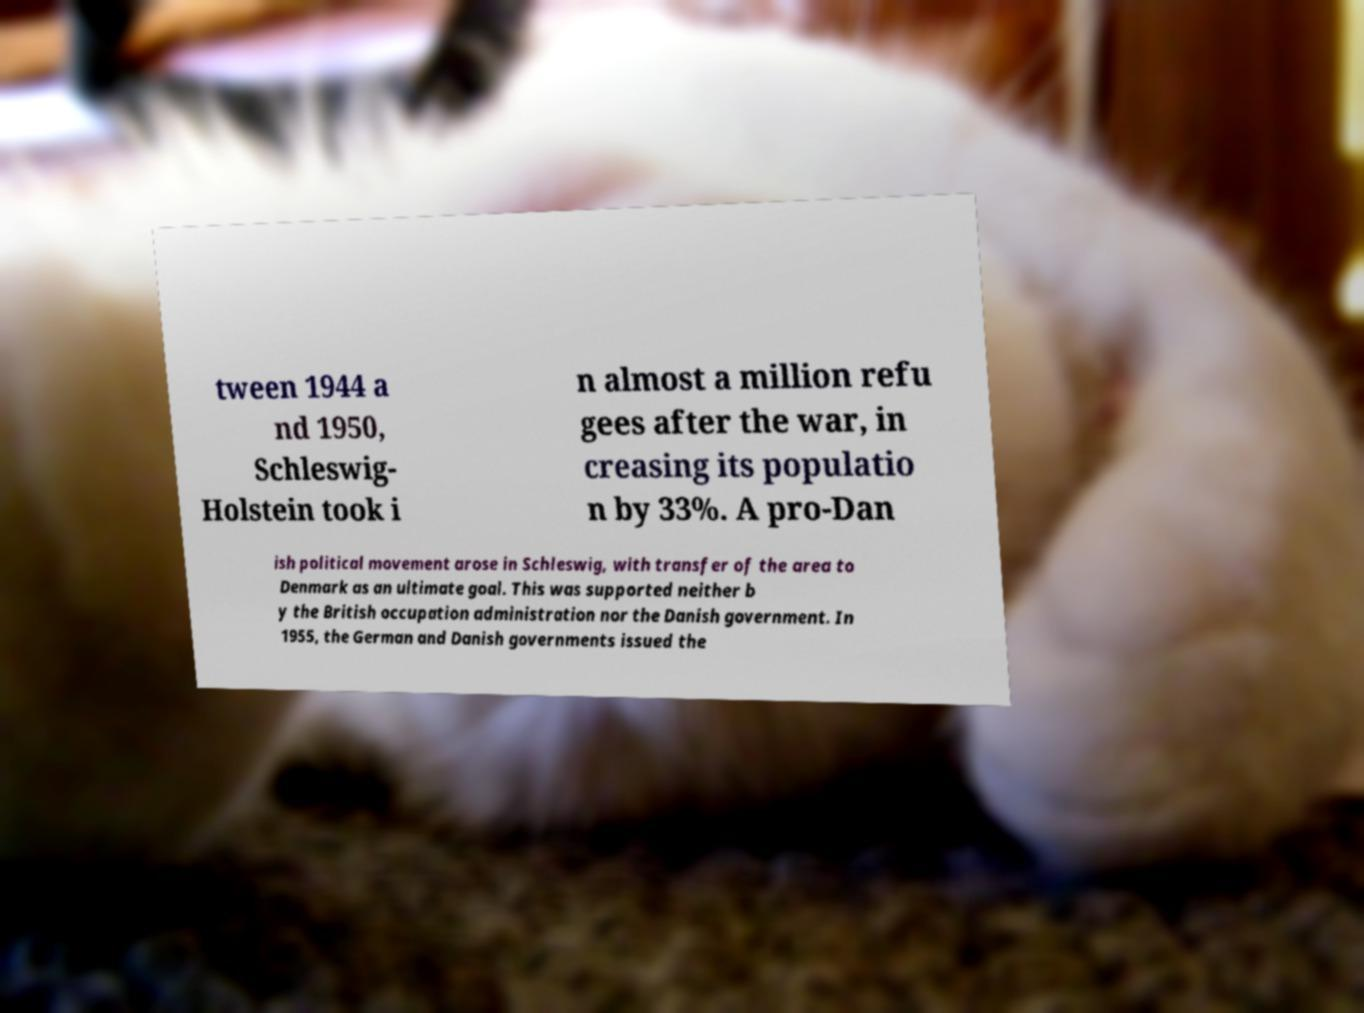Can you accurately transcribe the text from the provided image for me? tween 1944 a nd 1950, Schleswig- Holstein took i n almost a million refu gees after the war, in creasing its populatio n by 33%. A pro-Dan ish political movement arose in Schleswig, with transfer of the area to Denmark as an ultimate goal. This was supported neither b y the British occupation administration nor the Danish government. In 1955, the German and Danish governments issued the 